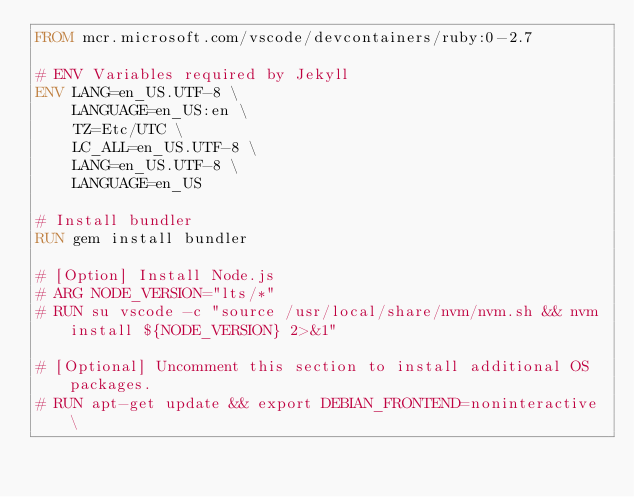<code> <loc_0><loc_0><loc_500><loc_500><_Dockerfile_>FROM mcr.microsoft.com/vscode/devcontainers/ruby:0-2.7

# ENV Variables required by Jekyll
ENV LANG=en_US.UTF-8 \
    LANGUAGE=en_US:en \
    TZ=Etc/UTC \
    LC_ALL=en_US.UTF-8 \
    LANG=en_US.UTF-8 \
    LANGUAGE=en_US

# Install bundler
RUN gem install bundler

# [Option] Install Node.js
# ARG NODE_VERSION="lts/*"
# RUN su vscode -c "source /usr/local/share/nvm/nvm.sh && nvm install ${NODE_VERSION} 2>&1"

# [Optional] Uncomment this section to install additional OS packages.
# RUN apt-get update && export DEBIAN_FRONTEND=noninteractive \</code> 